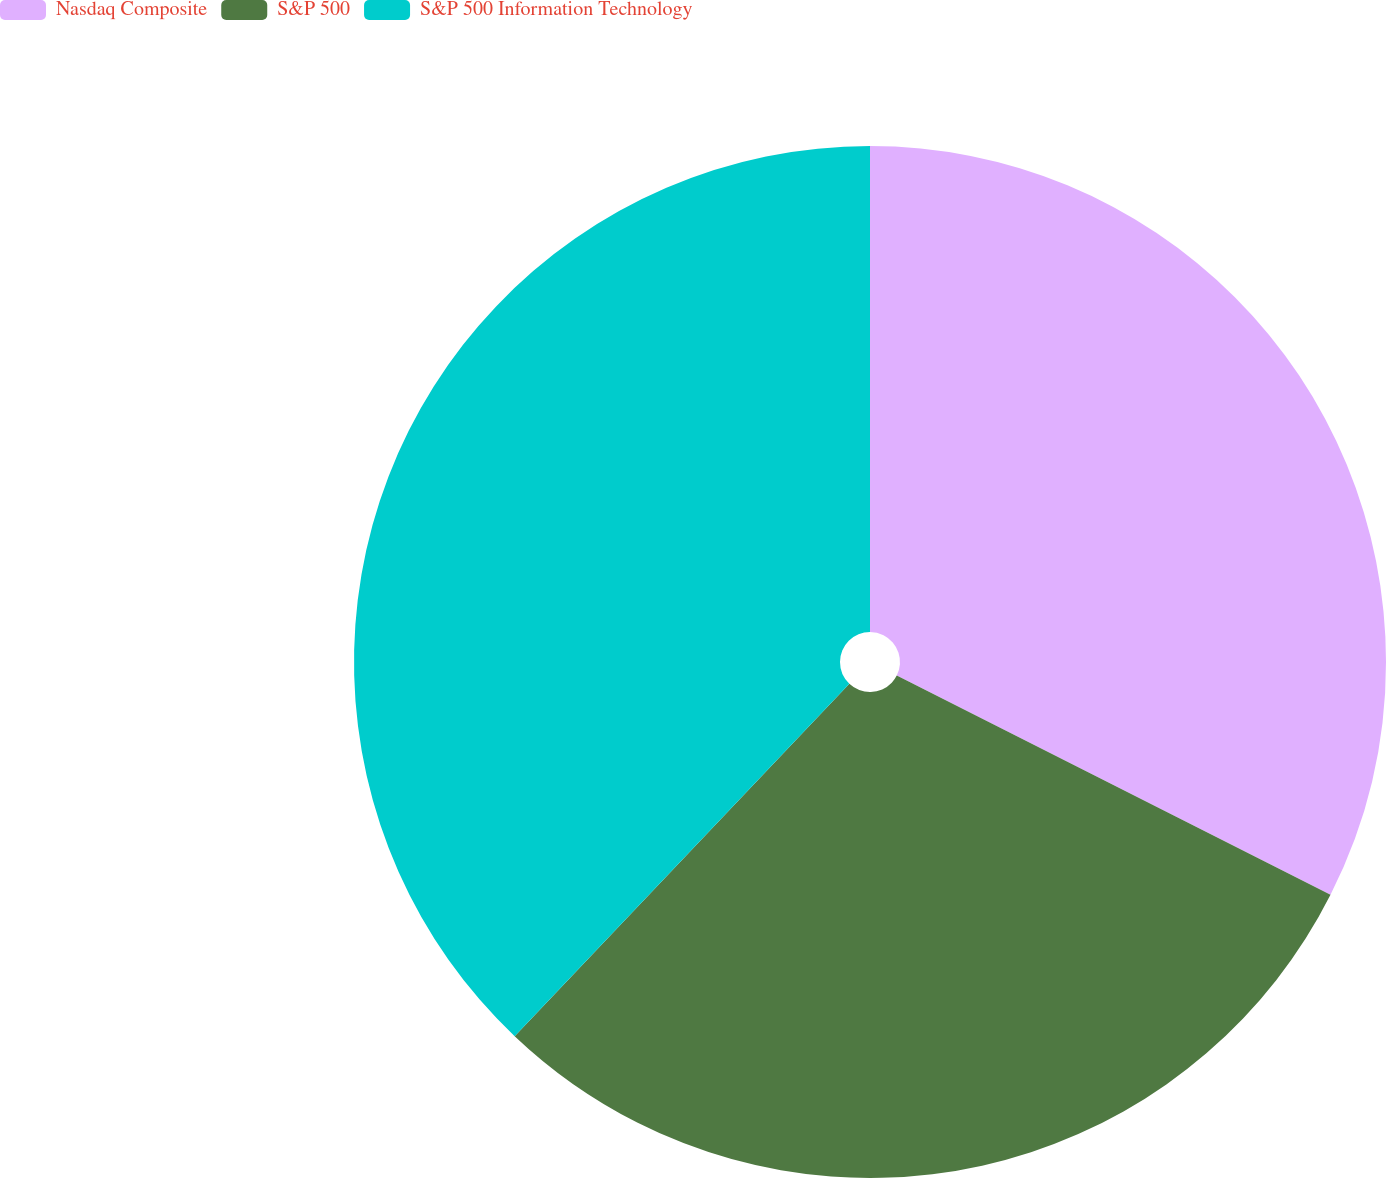Convert chart to OTSL. <chart><loc_0><loc_0><loc_500><loc_500><pie_chart><fcel>Nasdaq Composite<fcel>S&P 500<fcel>S&P 500 Information Technology<nl><fcel>32.45%<fcel>29.64%<fcel>37.91%<nl></chart> 